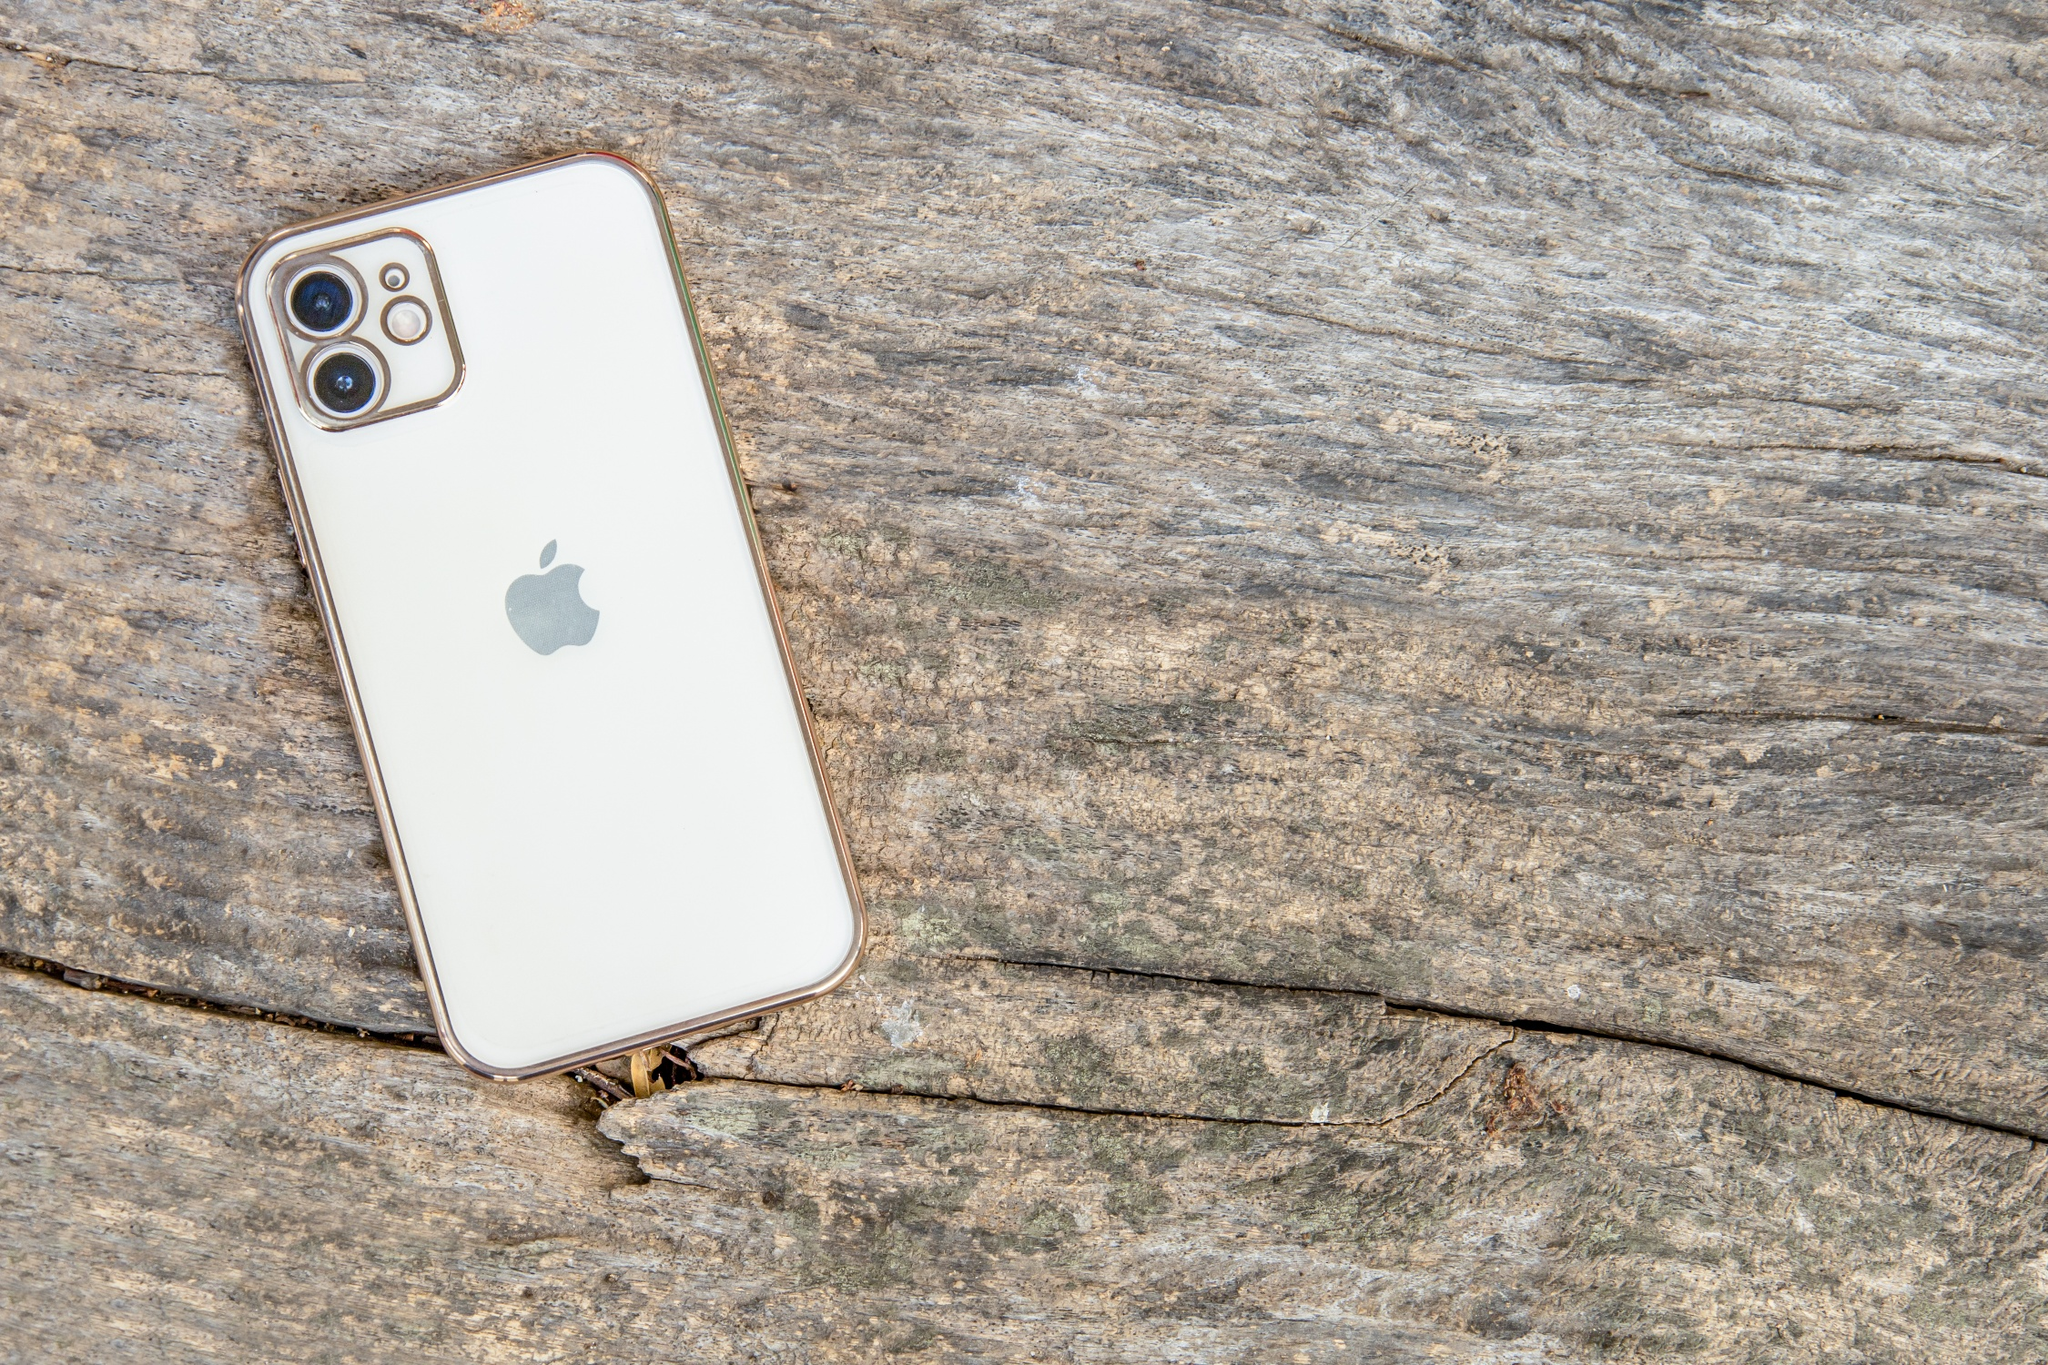Analyze the image in a comprehensive and detailed manner. The image features a white iPhone with a silver border resting on a rustic, weathered wooden surface. The wooden surface has multiple cracks, adding to its aged appearance. The iPhone is positioned diagonally with its back facing upward, showcasing the Apple logo which is prominently displayed in the center. The phone's three cameras are located in the top left corner. This perspective provides a clear, detailed view of the phone and the texture of the wood. The image captures a blend of modern technology and a natural, rugged background. The 'sa_14021' could possibly be a unique identifier or catalog number, however, it lacks context for further interpretation without additional information. 